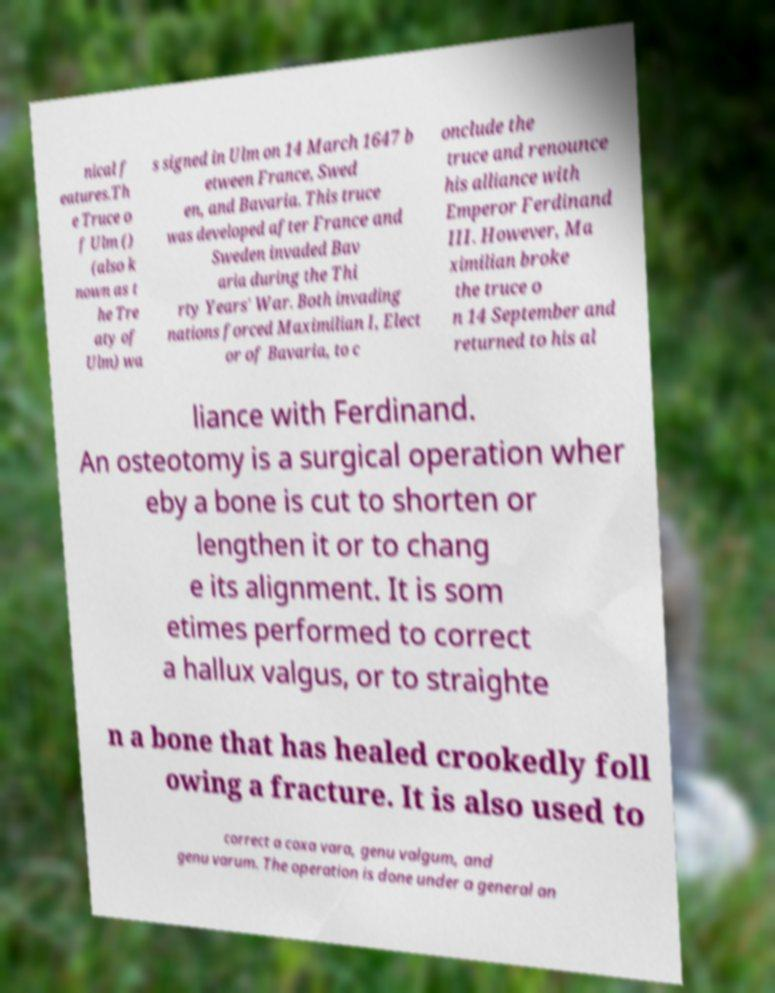Please identify and transcribe the text found in this image. nical f eatures.Th e Truce o f Ulm () (also k nown as t he Tre aty of Ulm) wa s signed in Ulm on 14 March 1647 b etween France, Swed en, and Bavaria. This truce was developed after France and Sweden invaded Bav aria during the Thi rty Years' War. Both invading nations forced Maximilian I, Elect or of Bavaria, to c onclude the truce and renounce his alliance with Emperor Ferdinand III. However, Ma ximilian broke the truce o n 14 September and returned to his al liance with Ferdinand. An osteotomy is a surgical operation wher eby a bone is cut to shorten or lengthen it or to chang e its alignment. It is som etimes performed to correct a hallux valgus, or to straighte n a bone that has healed crookedly foll owing a fracture. It is also used to correct a coxa vara, genu valgum, and genu varum. The operation is done under a general an 